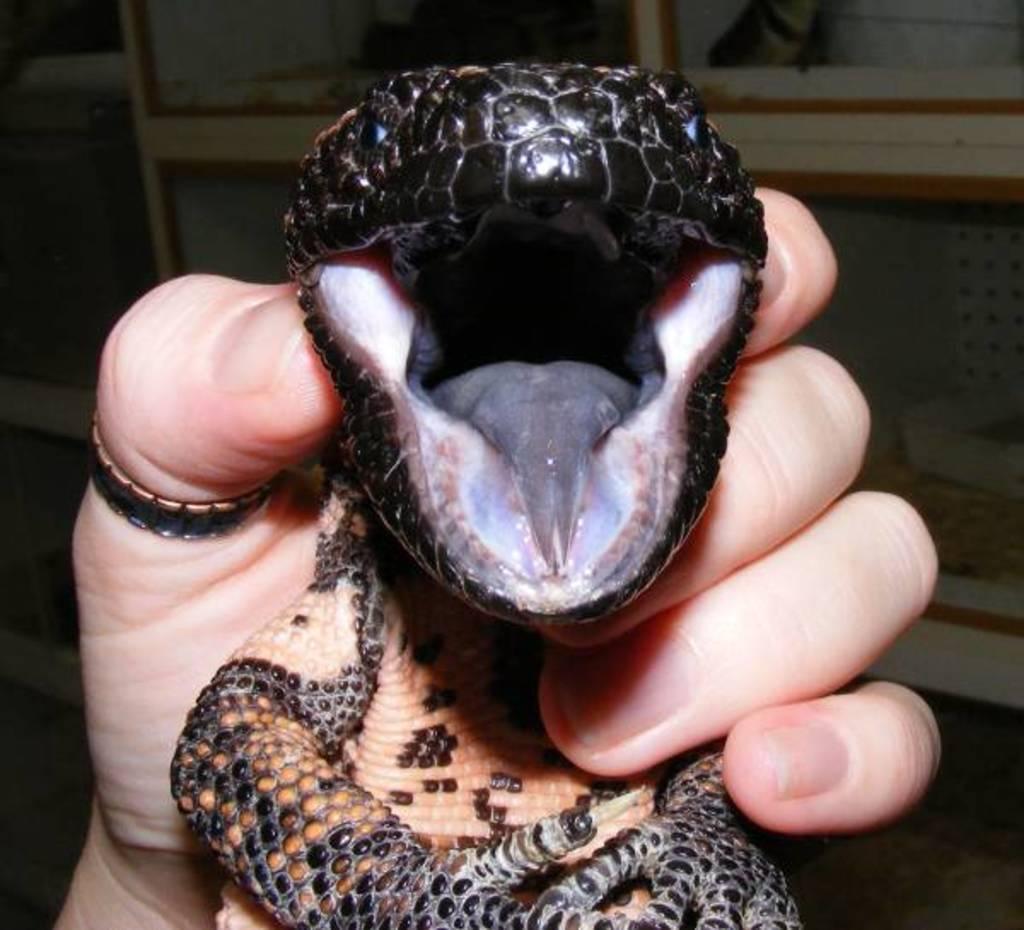Describe this image in one or two sentences. In this picture we can see a person is holding a reptile. 